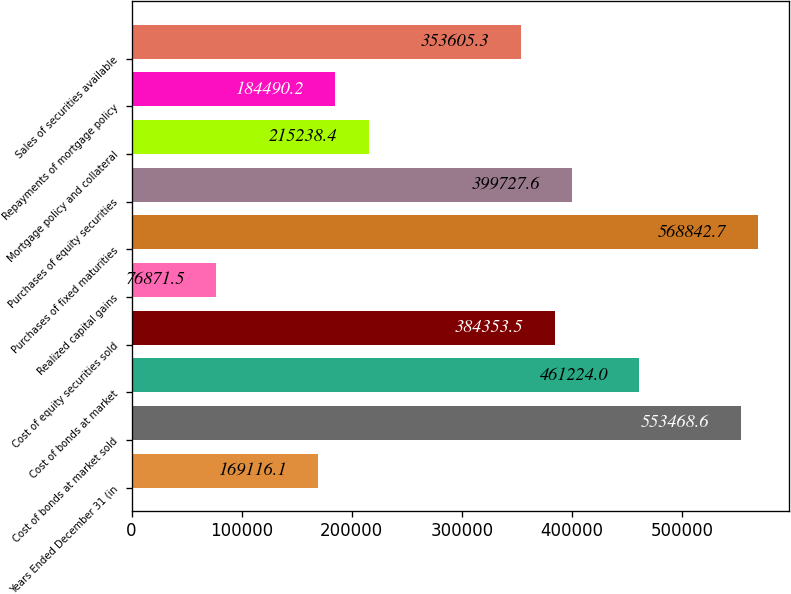Convert chart. <chart><loc_0><loc_0><loc_500><loc_500><bar_chart><fcel>Years Ended December 31 (in<fcel>Cost of bonds at market sold<fcel>Cost of bonds at market<fcel>Cost of equity securities sold<fcel>Realized capital gains<fcel>Purchases of fixed maturities<fcel>Purchases of equity securities<fcel>Mortgage policy and collateral<fcel>Repayments of mortgage policy<fcel>Sales of securities available<nl><fcel>169116<fcel>553469<fcel>461224<fcel>384354<fcel>76871.5<fcel>568843<fcel>399728<fcel>215238<fcel>184490<fcel>353605<nl></chart> 